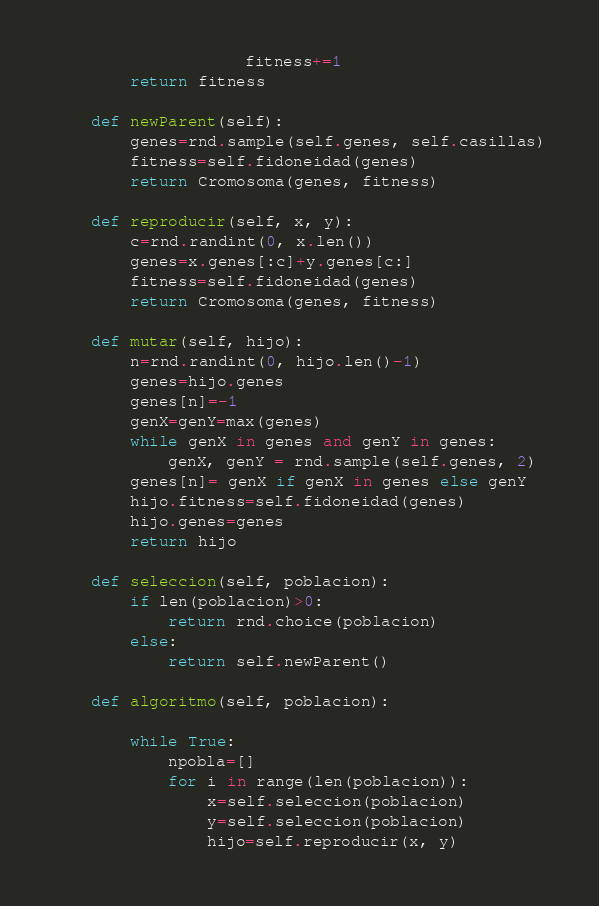<code> <loc_0><loc_0><loc_500><loc_500><_Python_>                    fitness+=1
        return fitness

    def newParent(self):
        genes=rnd.sample(self.genes, self.casillas)
        fitness=self.fidoneidad(genes)
        return Cromosoma(genes, fitness)

    def reproducir(self, x, y):
        c=rnd.randint(0, x.len())
        genes=x.genes[:c]+y.genes[c:]
        fitness=self.fidoneidad(genes)
        return Cromosoma(genes, fitness)

    def mutar(self, hijo):
        n=rnd.randint(0, hijo.len()-1)
        genes=hijo.genes
        genes[n]=-1
        genX=genY=max(genes)
        while genX in genes and genY in genes:
            genX, genY = rnd.sample(self.genes, 2)
        genes[n]= genX if genX in genes else genY
        hijo.fitness=self.fidoneidad(genes)
        hijo.genes=genes
        return hijo

    def seleccion(self, poblacion):
        if len(poblacion)>0:
            return rnd.choice(poblacion)
        else:
            return self.newParent()

    def algoritmo(self, poblacion):

        while True:
            npobla=[]
            for i in range(len(poblacion)):
                x=self.seleccion(poblacion)
                y=self.seleccion(poblacion)
                hijo=self.reproducir(x, y)</code> 